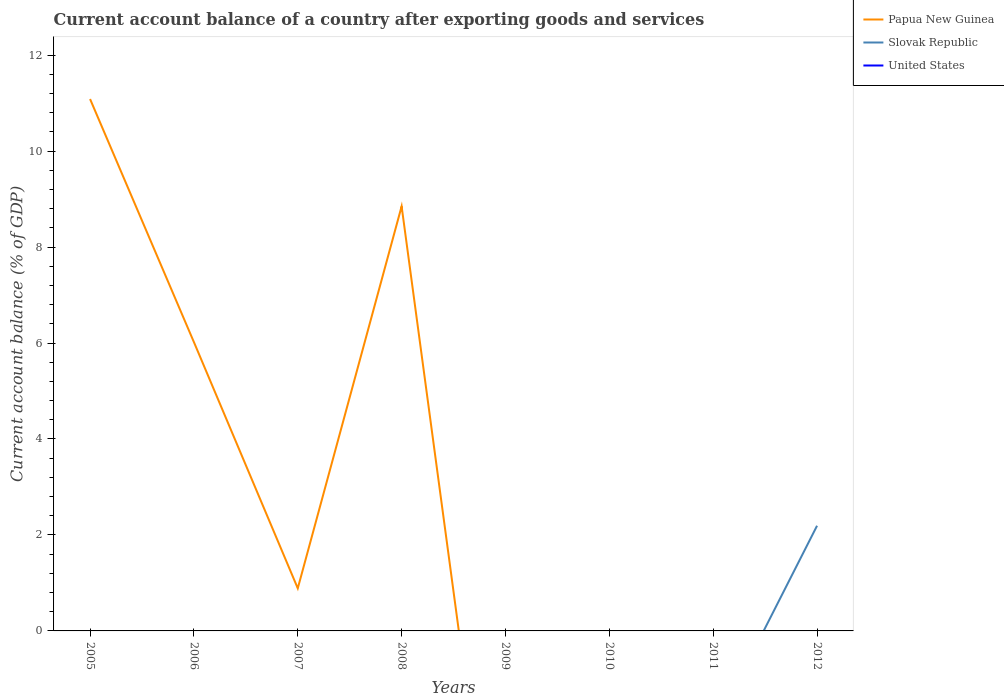How many different coloured lines are there?
Provide a short and direct response. 2. Does the line corresponding to Papua New Guinea intersect with the line corresponding to Slovak Republic?
Your answer should be very brief. Yes. What is the total account balance in Papua New Guinea in the graph?
Offer a very short reply. 5.07. What is the difference between the highest and the second highest account balance in Slovak Republic?
Offer a very short reply. 2.19. What is the difference between the highest and the lowest account balance in United States?
Offer a very short reply. 0. How many lines are there?
Provide a short and direct response. 2. What is the difference between two consecutive major ticks on the Y-axis?
Keep it short and to the point. 2. Where does the legend appear in the graph?
Your answer should be very brief. Top right. What is the title of the graph?
Keep it short and to the point. Current account balance of a country after exporting goods and services. Does "Aruba" appear as one of the legend labels in the graph?
Keep it short and to the point. No. What is the label or title of the X-axis?
Offer a very short reply. Years. What is the label or title of the Y-axis?
Provide a short and direct response. Current account balance (% of GDP). What is the Current account balance (% of GDP) in Papua New Guinea in 2005?
Your response must be concise. 11.09. What is the Current account balance (% of GDP) in United States in 2005?
Ensure brevity in your answer.  0. What is the Current account balance (% of GDP) of Papua New Guinea in 2006?
Keep it short and to the point. 6.02. What is the Current account balance (% of GDP) in Slovak Republic in 2006?
Your answer should be compact. 0. What is the Current account balance (% of GDP) of Papua New Guinea in 2007?
Give a very brief answer. 0.89. What is the Current account balance (% of GDP) of Papua New Guinea in 2008?
Give a very brief answer. 8.85. What is the Current account balance (% of GDP) of Slovak Republic in 2008?
Your answer should be compact. 0. What is the Current account balance (% of GDP) in United States in 2008?
Ensure brevity in your answer.  0. What is the Current account balance (% of GDP) in Papua New Guinea in 2009?
Make the answer very short. 0. What is the Current account balance (% of GDP) of Slovak Republic in 2009?
Your response must be concise. 0. What is the Current account balance (% of GDP) in Papua New Guinea in 2010?
Offer a terse response. 0. What is the Current account balance (% of GDP) in Slovak Republic in 2010?
Offer a terse response. 0. What is the Current account balance (% of GDP) in Slovak Republic in 2011?
Give a very brief answer. 0. What is the Current account balance (% of GDP) of Papua New Guinea in 2012?
Offer a terse response. 0. What is the Current account balance (% of GDP) in Slovak Republic in 2012?
Provide a short and direct response. 2.19. What is the Current account balance (% of GDP) of United States in 2012?
Provide a short and direct response. 0. Across all years, what is the maximum Current account balance (% of GDP) of Papua New Guinea?
Your response must be concise. 11.09. Across all years, what is the maximum Current account balance (% of GDP) of Slovak Republic?
Your answer should be very brief. 2.19. Across all years, what is the minimum Current account balance (% of GDP) of Papua New Guinea?
Make the answer very short. 0. Across all years, what is the minimum Current account balance (% of GDP) of Slovak Republic?
Your answer should be very brief. 0. What is the total Current account balance (% of GDP) in Papua New Guinea in the graph?
Give a very brief answer. 26.84. What is the total Current account balance (% of GDP) in Slovak Republic in the graph?
Your answer should be compact. 2.19. What is the total Current account balance (% of GDP) in United States in the graph?
Offer a terse response. 0. What is the difference between the Current account balance (% of GDP) of Papua New Guinea in 2005 and that in 2006?
Keep it short and to the point. 5.07. What is the difference between the Current account balance (% of GDP) of Papua New Guinea in 2005 and that in 2007?
Your answer should be compact. 10.2. What is the difference between the Current account balance (% of GDP) of Papua New Guinea in 2005 and that in 2008?
Provide a succinct answer. 2.24. What is the difference between the Current account balance (% of GDP) in Papua New Guinea in 2006 and that in 2007?
Ensure brevity in your answer.  5.13. What is the difference between the Current account balance (% of GDP) in Papua New Guinea in 2006 and that in 2008?
Provide a succinct answer. -2.83. What is the difference between the Current account balance (% of GDP) in Papua New Guinea in 2007 and that in 2008?
Provide a succinct answer. -7.96. What is the difference between the Current account balance (% of GDP) of Papua New Guinea in 2005 and the Current account balance (% of GDP) of Slovak Republic in 2012?
Ensure brevity in your answer.  8.89. What is the difference between the Current account balance (% of GDP) of Papua New Guinea in 2006 and the Current account balance (% of GDP) of Slovak Republic in 2012?
Your response must be concise. 3.83. What is the difference between the Current account balance (% of GDP) in Papua New Guinea in 2007 and the Current account balance (% of GDP) in Slovak Republic in 2012?
Offer a terse response. -1.3. What is the difference between the Current account balance (% of GDP) in Papua New Guinea in 2008 and the Current account balance (% of GDP) in Slovak Republic in 2012?
Make the answer very short. 6.66. What is the average Current account balance (% of GDP) of Papua New Guinea per year?
Your answer should be compact. 3.36. What is the average Current account balance (% of GDP) in Slovak Republic per year?
Provide a succinct answer. 0.27. What is the average Current account balance (% of GDP) in United States per year?
Offer a terse response. 0. What is the ratio of the Current account balance (% of GDP) of Papua New Guinea in 2005 to that in 2006?
Ensure brevity in your answer.  1.84. What is the ratio of the Current account balance (% of GDP) in Papua New Guinea in 2005 to that in 2007?
Keep it short and to the point. 12.48. What is the ratio of the Current account balance (% of GDP) in Papua New Guinea in 2005 to that in 2008?
Your response must be concise. 1.25. What is the ratio of the Current account balance (% of GDP) in Papua New Guinea in 2006 to that in 2007?
Your response must be concise. 6.78. What is the ratio of the Current account balance (% of GDP) of Papua New Guinea in 2006 to that in 2008?
Provide a short and direct response. 0.68. What is the ratio of the Current account balance (% of GDP) in Papua New Guinea in 2007 to that in 2008?
Provide a short and direct response. 0.1. What is the difference between the highest and the second highest Current account balance (% of GDP) of Papua New Guinea?
Make the answer very short. 2.24. What is the difference between the highest and the lowest Current account balance (% of GDP) of Papua New Guinea?
Ensure brevity in your answer.  11.09. What is the difference between the highest and the lowest Current account balance (% of GDP) of Slovak Republic?
Your answer should be compact. 2.19. 